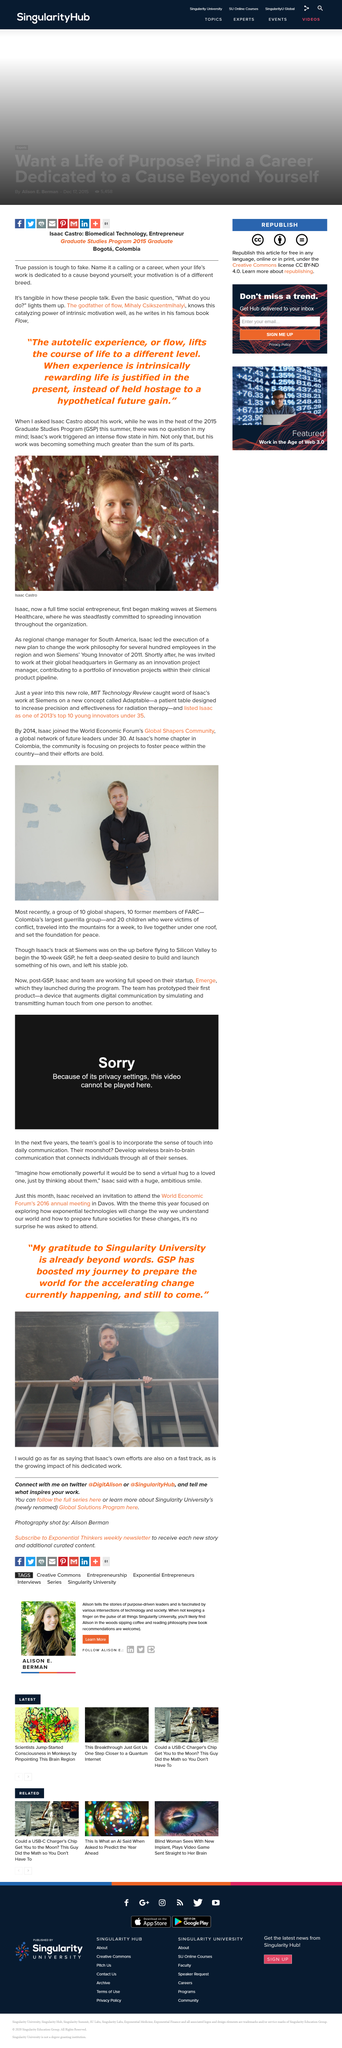Point out several critical features in this image. Isaac Castro is a full-time social entrepreneur who has made a name for himself at Siemens healthcare. Isaac Castro was awarded the title of Siemens' young innovator of 2011 for his outstanding achievement in that year. Isaac Castro is present in the image. 